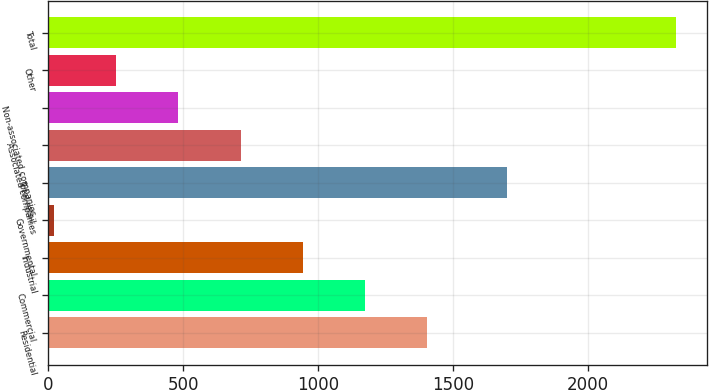Convert chart. <chart><loc_0><loc_0><loc_500><loc_500><bar_chart><fcel>Residential<fcel>Commercial<fcel>Industrial<fcel>Governmental<fcel>Total retail<fcel>Associated companies<fcel>Non-associated companies<fcel>Other<fcel>Total<nl><fcel>1405.2<fcel>1174.5<fcel>943.8<fcel>21<fcel>1701<fcel>713.1<fcel>482.4<fcel>251.7<fcel>2328<nl></chart> 